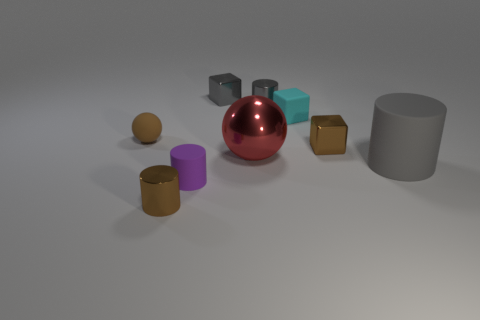The small matte thing that is the same shape as the large gray rubber object is what color?
Your answer should be very brief. Purple. There is a large thing that is made of the same material as the small purple thing; what is its color?
Provide a succinct answer. Gray. How many other red metallic things have the same size as the red metal thing?
Your answer should be very brief. 0. What material is the brown block?
Provide a short and direct response. Metal. Are there more rubber objects than small brown spheres?
Make the answer very short. Yes. Does the cyan thing have the same shape as the tiny brown matte object?
Your response must be concise. No. Is there anything else that has the same shape as the cyan rubber object?
Make the answer very short. Yes. There is a small rubber thing right of the red object; does it have the same color as the small matte thing that is to the left of the brown cylinder?
Your answer should be compact. No. Are there fewer small cylinders that are to the right of the small rubber block than red shiny objects that are on the right side of the big gray rubber object?
Your answer should be compact. No. What is the shape of the tiny matte object behind the brown ball?
Your answer should be compact. Cube. 